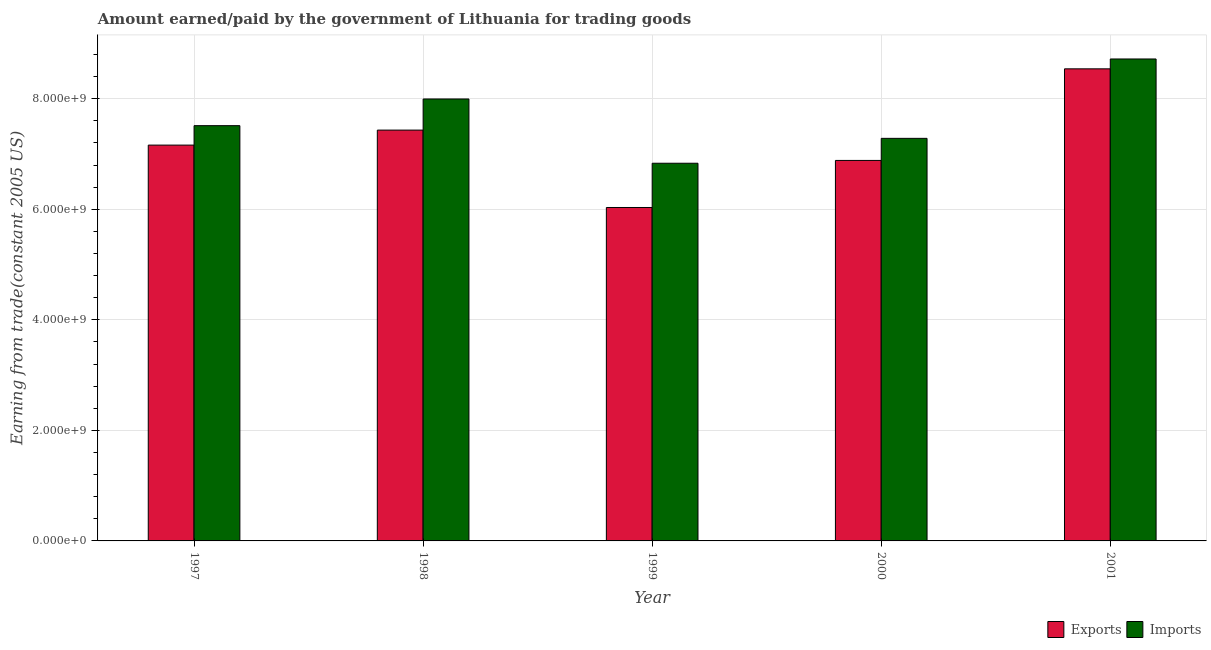How many different coloured bars are there?
Offer a very short reply. 2. How many groups of bars are there?
Your answer should be very brief. 5. Are the number of bars per tick equal to the number of legend labels?
Your answer should be compact. Yes. How many bars are there on the 5th tick from the left?
Your response must be concise. 2. How many bars are there on the 1st tick from the right?
Offer a very short reply. 2. What is the label of the 5th group of bars from the left?
Ensure brevity in your answer.  2001. In how many cases, is the number of bars for a given year not equal to the number of legend labels?
Provide a succinct answer. 0. What is the amount earned from exports in 1999?
Ensure brevity in your answer.  6.03e+09. Across all years, what is the maximum amount paid for imports?
Make the answer very short. 8.72e+09. Across all years, what is the minimum amount earned from exports?
Ensure brevity in your answer.  6.03e+09. What is the total amount paid for imports in the graph?
Give a very brief answer. 3.83e+1. What is the difference between the amount earned from exports in 1997 and that in 2000?
Keep it short and to the point. 2.77e+08. What is the difference between the amount earned from exports in 2000 and the amount paid for imports in 1998?
Ensure brevity in your answer.  -5.49e+08. What is the average amount paid for imports per year?
Provide a succinct answer. 7.67e+09. In how many years, is the amount paid for imports greater than 8400000000 US$?
Make the answer very short. 1. What is the ratio of the amount earned from exports in 1997 to that in 1998?
Give a very brief answer. 0.96. What is the difference between the highest and the second highest amount earned from exports?
Offer a terse response. 1.11e+09. What is the difference between the highest and the lowest amount earned from exports?
Provide a short and direct response. 2.51e+09. In how many years, is the amount earned from exports greater than the average amount earned from exports taken over all years?
Ensure brevity in your answer.  2. Is the sum of the amount earned from exports in 1998 and 1999 greater than the maximum amount paid for imports across all years?
Provide a succinct answer. Yes. What does the 1st bar from the left in 1998 represents?
Ensure brevity in your answer.  Exports. What does the 1st bar from the right in 2000 represents?
Keep it short and to the point. Imports. How many bars are there?
Give a very brief answer. 10. Are all the bars in the graph horizontal?
Your response must be concise. No. What is the difference between two consecutive major ticks on the Y-axis?
Provide a succinct answer. 2.00e+09. Does the graph contain any zero values?
Your response must be concise. No. Does the graph contain grids?
Make the answer very short. Yes. Where does the legend appear in the graph?
Your answer should be very brief. Bottom right. How many legend labels are there?
Give a very brief answer. 2. How are the legend labels stacked?
Keep it short and to the point. Horizontal. What is the title of the graph?
Provide a short and direct response. Amount earned/paid by the government of Lithuania for trading goods. Does "Passenger Transport Items" appear as one of the legend labels in the graph?
Provide a succinct answer. No. What is the label or title of the Y-axis?
Make the answer very short. Earning from trade(constant 2005 US). What is the Earning from trade(constant 2005 US) of Exports in 1997?
Ensure brevity in your answer.  7.16e+09. What is the Earning from trade(constant 2005 US) of Imports in 1997?
Offer a very short reply. 7.51e+09. What is the Earning from trade(constant 2005 US) of Exports in 1998?
Ensure brevity in your answer.  7.43e+09. What is the Earning from trade(constant 2005 US) of Imports in 1998?
Offer a terse response. 8.00e+09. What is the Earning from trade(constant 2005 US) of Exports in 1999?
Provide a short and direct response. 6.03e+09. What is the Earning from trade(constant 2005 US) of Imports in 1999?
Your answer should be compact. 6.83e+09. What is the Earning from trade(constant 2005 US) of Exports in 2000?
Provide a short and direct response. 6.88e+09. What is the Earning from trade(constant 2005 US) in Imports in 2000?
Provide a short and direct response. 7.28e+09. What is the Earning from trade(constant 2005 US) of Exports in 2001?
Make the answer very short. 8.54e+09. What is the Earning from trade(constant 2005 US) of Imports in 2001?
Provide a succinct answer. 8.72e+09. Across all years, what is the maximum Earning from trade(constant 2005 US) of Exports?
Your answer should be compact. 8.54e+09. Across all years, what is the maximum Earning from trade(constant 2005 US) of Imports?
Provide a succinct answer. 8.72e+09. Across all years, what is the minimum Earning from trade(constant 2005 US) in Exports?
Your answer should be compact. 6.03e+09. Across all years, what is the minimum Earning from trade(constant 2005 US) of Imports?
Offer a very short reply. 6.83e+09. What is the total Earning from trade(constant 2005 US) in Exports in the graph?
Offer a terse response. 3.61e+1. What is the total Earning from trade(constant 2005 US) of Imports in the graph?
Ensure brevity in your answer.  3.83e+1. What is the difference between the Earning from trade(constant 2005 US) of Exports in 1997 and that in 1998?
Keep it short and to the point. -2.72e+08. What is the difference between the Earning from trade(constant 2005 US) in Imports in 1997 and that in 1998?
Provide a short and direct response. -4.83e+08. What is the difference between the Earning from trade(constant 2005 US) of Exports in 1997 and that in 1999?
Your answer should be compact. 1.13e+09. What is the difference between the Earning from trade(constant 2005 US) of Imports in 1997 and that in 1999?
Keep it short and to the point. 6.80e+08. What is the difference between the Earning from trade(constant 2005 US) in Exports in 1997 and that in 2000?
Your answer should be compact. 2.77e+08. What is the difference between the Earning from trade(constant 2005 US) in Imports in 1997 and that in 2000?
Your answer should be compact. 2.30e+08. What is the difference between the Earning from trade(constant 2005 US) of Exports in 1997 and that in 2001?
Make the answer very short. -1.38e+09. What is the difference between the Earning from trade(constant 2005 US) of Imports in 1997 and that in 2001?
Offer a terse response. -1.21e+09. What is the difference between the Earning from trade(constant 2005 US) of Exports in 1998 and that in 1999?
Ensure brevity in your answer.  1.40e+09. What is the difference between the Earning from trade(constant 2005 US) of Imports in 1998 and that in 1999?
Provide a succinct answer. 1.16e+09. What is the difference between the Earning from trade(constant 2005 US) in Exports in 1998 and that in 2000?
Keep it short and to the point. 5.49e+08. What is the difference between the Earning from trade(constant 2005 US) in Imports in 1998 and that in 2000?
Offer a very short reply. 7.12e+08. What is the difference between the Earning from trade(constant 2005 US) in Exports in 1998 and that in 2001?
Offer a terse response. -1.11e+09. What is the difference between the Earning from trade(constant 2005 US) in Imports in 1998 and that in 2001?
Make the answer very short. -7.24e+08. What is the difference between the Earning from trade(constant 2005 US) in Exports in 1999 and that in 2000?
Offer a very short reply. -8.52e+08. What is the difference between the Earning from trade(constant 2005 US) of Imports in 1999 and that in 2000?
Your answer should be very brief. -4.50e+08. What is the difference between the Earning from trade(constant 2005 US) in Exports in 1999 and that in 2001?
Your response must be concise. -2.51e+09. What is the difference between the Earning from trade(constant 2005 US) in Imports in 1999 and that in 2001?
Ensure brevity in your answer.  -1.89e+09. What is the difference between the Earning from trade(constant 2005 US) in Exports in 2000 and that in 2001?
Give a very brief answer. -1.66e+09. What is the difference between the Earning from trade(constant 2005 US) of Imports in 2000 and that in 2001?
Offer a very short reply. -1.44e+09. What is the difference between the Earning from trade(constant 2005 US) of Exports in 1997 and the Earning from trade(constant 2005 US) of Imports in 1998?
Make the answer very short. -8.35e+08. What is the difference between the Earning from trade(constant 2005 US) of Exports in 1997 and the Earning from trade(constant 2005 US) of Imports in 1999?
Offer a very short reply. 3.28e+08. What is the difference between the Earning from trade(constant 2005 US) in Exports in 1997 and the Earning from trade(constant 2005 US) in Imports in 2000?
Your response must be concise. -1.22e+08. What is the difference between the Earning from trade(constant 2005 US) of Exports in 1997 and the Earning from trade(constant 2005 US) of Imports in 2001?
Provide a succinct answer. -1.56e+09. What is the difference between the Earning from trade(constant 2005 US) of Exports in 1998 and the Earning from trade(constant 2005 US) of Imports in 1999?
Make the answer very short. 6.00e+08. What is the difference between the Earning from trade(constant 2005 US) in Exports in 1998 and the Earning from trade(constant 2005 US) in Imports in 2000?
Keep it short and to the point. 1.49e+08. What is the difference between the Earning from trade(constant 2005 US) of Exports in 1998 and the Earning from trade(constant 2005 US) of Imports in 2001?
Your response must be concise. -1.29e+09. What is the difference between the Earning from trade(constant 2005 US) in Exports in 1999 and the Earning from trade(constant 2005 US) in Imports in 2000?
Give a very brief answer. -1.25e+09. What is the difference between the Earning from trade(constant 2005 US) of Exports in 1999 and the Earning from trade(constant 2005 US) of Imports in 2001?
Provide a succinct answer. -2.69e+09. What is the difference between the Earning from trade(constant 2005 US) in Exports in 2000 and the Earning from trade(constant 2005 US) in Imports in 2001?
Provide a short and direct response. -1.84e+09. What is the average Earning from trade(constant 2005 US) of Exports per year?
Offer a terse response. 7.21e+09. What is the average Earning from trade(constant 2005 US) of Imports per year?
Your answer should be compact. 7.67e+09. In the year 1997, what is the difference between the Earning from trade(constant 2005 US) of Exports and Earning from trade(constant 2005 US) of Imports?
Your answer should be compact. -3.52e+08. In the year 1998, what is the difference between the Earning from trade(constant 2005 US) of Exports and Earning from trade(constant 2005 US) of Imports?
Keep it short and to the point. -5.63e+08. In the year 1999, what is the difference between the Earning from trade(constant 2005 US) in Exports and Earning from trade(constant 2005 US) in Imports?
Make the answer very short. -8.01e+08. In the year 2000, what is the difference between the Earning from trade(constant 2005 US) of Exports and Earning from trade(constant 2005 US) of Imports?
Your answer should be compact. -4.00e+08. In the year 2001, what is the difference between the Earning from trade(constant 2005 US) in Exports and Earning from trade(constant 2005 US) in Imports?
Make the answer very short. -1.79e+08. What is the ratio of the Earning from trade(constant 2005 US) of Exports in 1997 to that in 1998?
Ensure brevity in your answer.  0.96. What is the ratio of the Earning from trade(constant 2005 US) of Imports in 1997 to that in 1998?
Keep it short and to the point. 0.94. What is the ratio of the Earning from trade(constant 2005 US) of Exports in 1997 to that in 1999?
Offer a very short reply. 1.19. What is the ratio of the Earning from trade(constant 2005 US) in Imports in 1997 to that in 1999?
Offer a terse response. 1.1. What is the ratio of the Earning from trade(constant 2005 US) of Exports in 1997 to that in 2000?
Your answer should be very brief. 1.04. What is the ratio of the Earning from trade(constant 2005 US) in Imports in 1997 to that in 2000?
Your answer should be compact. 1.03. What is the ratio of the Earning from trade(constant 2005 US) of Exports in 1997 to that in 2001?
Provide a succinct answer. 0.84. What is the ratio of the Earning from trade(constant 2005 US) in Imports in 1997 to that in 2001?
Provide a short and direct response. 0.86. What is the ratio of the Earning from trade(constant 2005 US) of Exports in 1998 to that in 1999?
Your answer should be very brief. 1.23. What is the ratio of the Earning from trade(constant 2005 US) in Imports in 1998 to that in 1999?
Your answer should be very brief. 1.17. What is the ratio of the Earning from trade(constant 2005 US) of Exports in 1998 to that in 2000?
Offer a very short reply. 1.08. What is the ratio of the Earning from trade(constant 2005 US) of Imports in 1998 to that in 2000?
Offer a very short reply. 1.1. What is the ratio of the Earning from trade(constant 2005 US) in Exports in 1998 to that in 2001?
Your answer should be very brief. 0.87. What is the ratio of the Earning from trade(constant 2005 US) of Imports in 1998 to that in 2001?
Ensure brevity in your answer.  0.92. What is the ratio of the Earning from trade(constant 2005 US) in Exports in 1999 to that in 2000?
Your answer should be very brief. 0.88. What is the ratio of the Earning from trade(constant 2005 US) in Imports in 1999 to that in 2000?
Make the answer very short. 0.94. What is the ratio of the Earning from trade(constant 2005 US) of Exports in 1999 to that in 2001?
Provide a short and direct response. 0.71. What is the ratio of the Earning from trade(constant 2005 US) in Imports in 1999 to that in 2001?
Provide a short and direct response. 0.78. What is the ratio of the Earning from trade(constant 2005 US) in Exports in 2000 to that in 2001?
Give a very brief answer. 0.81. What is the ratio of the Earning from trade(constant 2005 US) in Imports in 2000 to that in 2001?
Give a very brief answer. 0.84. What is the difference between the highest and the second highest Earning from trade(constant 2005 US) in Exports?
Your answer should be compact. 1.11e+09. What is the difference between the highest and the second highest Earning from trade(constant 2005 US) in Imports?
Your answer should be compact. 7.24e+08. What is the difference between the highest and the lowest Earning from trade(constant 2005 US) in Exports?
Offer a very short reply. 2.51e+09. What is the difference between the highest and the lowest Earning from trade(constant 2005 US) of Imports?
Provide a short and direct response. 1.89e+09. 